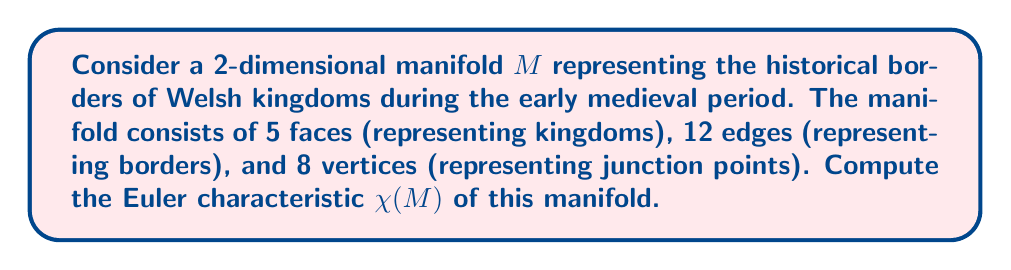Solve this math problem. To compute the Euler characteristic of the manifold $M$, we will use the following steps:

1. Recall the formula for the Euler characteristic of a 2-dimensional manifold:

   $$\chi(M) = V - E + F$$

   where $V$ is the number of vertices, $E$ is the number of edges, and $F$ is the number of faces.

2. From the given information:
   - Number of faces (kingdoms): $F = 5$
   - Number of edges (borders): $E = 12$
   - Number of vertices (junction points): $V = 8$

3. Substitute these values into the Euler characteristic formula:

   $$\chi(M) = V - E + F$$
   $$\chi(M) = 8 - 12 + 5$$

4. Perform the calculation:

   $$\chi(M) = 1$$

The Euler characteristic of 1 suggests that this manifold is topologically equivalent to a sphere. This makes sense in the context of Welsh kingdoms, as they collectively covered a contiguous land area that could be projected onto a sphere.

Note: In reality, the borders of Welsh kingdoms were more complex and changed over time. This simplified model serves to illustrate the concept of Euler characteristic in the context of Welsh history.
Answer: $\chi(M) = 1$ 